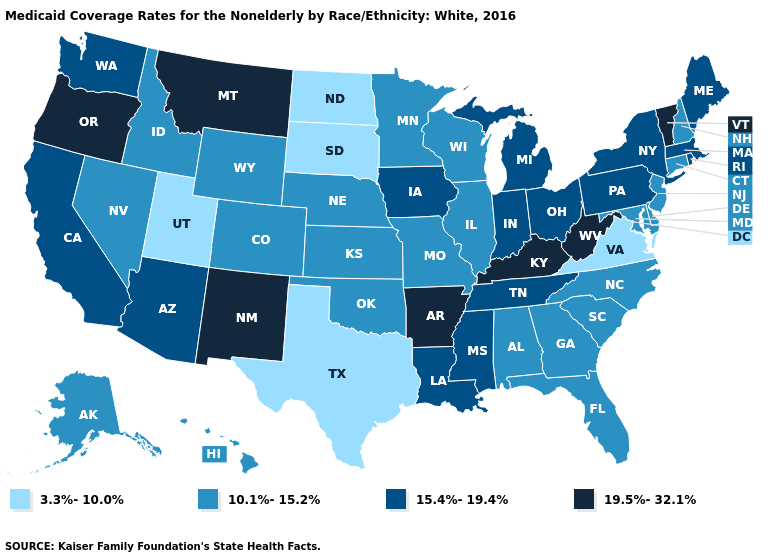What is the value of Maryland?
Quick response, please. 10.1%-15.2%. Among the states that border Rhode Island , which have the lowest value?
Quick response, please. Connecticut. What is the lowest value in the Northeast?
Keep it brief. 10.1%-15.2%. Name the states that have a value in the range 19.5%-32.1%?
Write a very short answer. Arkansas, Kentucky, Montana, New Mexico, Oregon, Vermont, West Virginia. Name the states that have a value in the range 3.3%-10.0%?
Give a very brief answer. North Dakota, South Dakota, Texas, Utah, Virginia. Does Washington have a lower value than Colorado?
Keep it brief. No. Is the legend a continuous bar?
Keep it brief. No. Among the states that border New Hampshire , which have the lowest value?
Answer briefly. Maine, Massachusetts. What is the value of North Carolina?
Keep it brief. 10.1%-15.2%. Among the states that border Kentucky , does Missouri have the lowest value?
Quick response, please. No. Name the states that have a value in the range 19.5%-32.1%?
Concise answer only. Arkansas, Kentucky, Montana, New Mexico, Oregon, Vermont, West Virginia. What is the highest value in the USA?
Give a very brief answer. 19.5%-32.1%. Name the states that have a value in the range 15.4%-19.4%?
Quick response, please. Arizona, California, Indiana, Iowa, Louisiana, Maine, Massachusetts, Michigan, Mississippi, New York, Ohio, Pennsylvania, Rhode Island, Tennessee, Washington. Name the states that have a value in the range 3.3%-10.0%?
Quick response, please. North Dakota, South Dakota, Texas, Utah, Virginia. Name the states that have a value in the range 19.5%-32.1%?
Quick response, please. Arkansas, Kentucky, Montana, New Mexico, Oregon, Vermont, West Virginia. 